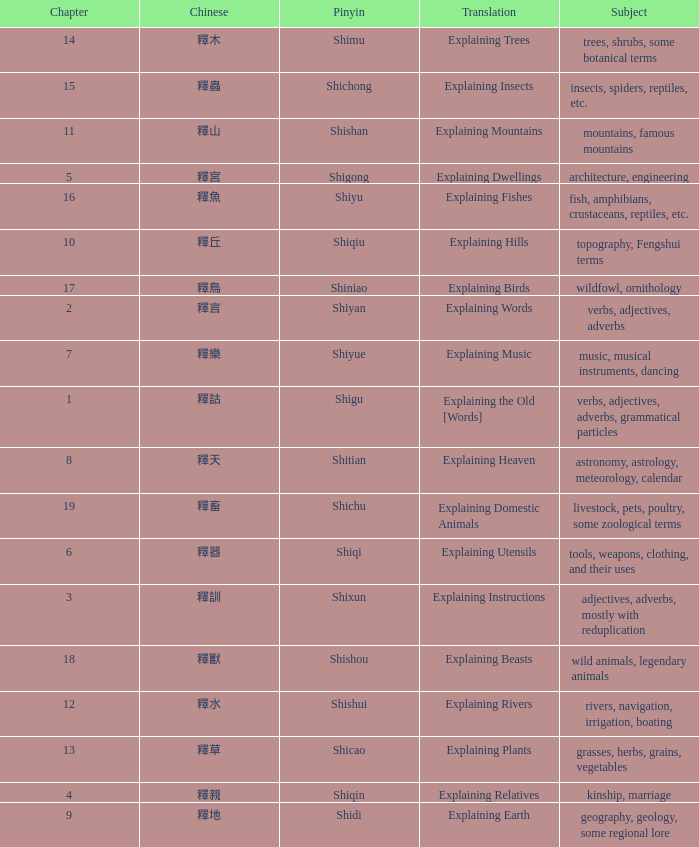Name the chinese with subject of adjectives, adverbs, mostly with reduplication 釋訓. Parse the full table. {'header': ['Chapter', 'Chinese', 'Pinyin', 'Translation', 'Subject'], 'rows': [['14', '釋木', 'Shimu', 'Explaining Trees', 'trees, shrubs, some botanical terms'], ['15', '釋蟲', 'Shichong', 'Explaining Insects', 'insects, spiders, reptiles, etc.'], ['11', '釋山', 'Shishan', 'Explaining Mountains', 'mountains, famous mountains'], ['5', '釋宮', 'Shigong', 'Explaining Dwellings', 'architecture, engineering'], ['16', '釋魚', 'Shiyu', 'Explaining Fishes', 'fish, amphibians, crustaceans, reptiles, etc.'], ['10', '釋丘', 'Shiqiu', 'Explaining Hills', 'topography, Fengshui terms'], ['17', '釋鳥', 'Shiniao', 'Explaining Birds', 'wildfowl, ornithology'], ['2', '釋言', 'Shiyan', 'Explaining Words', 'verbs, adjectives, adverbs'], ['7', '釋樂', 'Shiyue', 'Explaining Music', 'music, musical instruments, dancing'], ['1', '釋詁', 'Shigu', 'Explaining the Old [Words]', 'verbs, adjectives, adverbs, grammatical particles'], ['8', '釋天', 'Shitian', 'Explaining Heaven', 'astronomy, astrology, meteorology, calendar'], ['19', '釋畜', 'Shichu', 'Explaining Domestic Animals', 'livestock, pets, poultry, some zoological terms'], ['6', '釋器', 'Shiqi', 'Explaining Utensils', 'tools, weapons, clothing, and their uses'], ['3', '釋訓', 'Shixun', 'Explaining Instructions', 'adjectives, adverbs, mostly with reduplication'], ['18', '釋獸', 'Shishou', 'Explaining Beasts', 'wild animals, legendary animals'], ['12', '釋水', 'Shishui', 'Explaining Rivers', 'rivers, navigation, irrigation, boating'], ['13', '釋草', 'Shicao', 'Explaining Plants', 'grasses, herbs, grains, vegetables'], ['4', '釋親', 'Shiqin', 'Explaining Relatives', 'kinship, marriage'], ['9', '釋地', 'Shidi', 'Explaining Earth', 'geography, geology, some regional lore']]} 